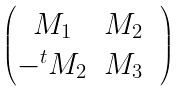Convert formula to latex. <formula><loc_0><loc_0><loc_500><loc_500>\begin{pmatrix} M _ { 1 } & M _ { 2 } & \\ - ^ { t } M _ { 2 } & M _ { 3 } \end{pmatrix}</formula> 